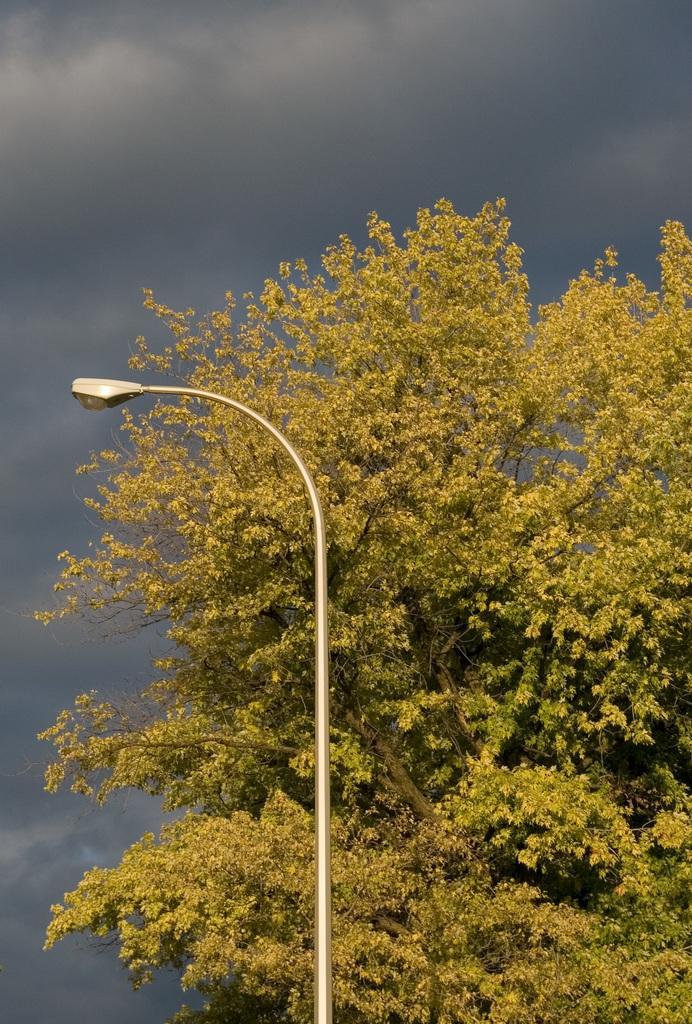Describe this image in one or two sentences. In this image I can see a tree and a light pole. In the background I can see the sky. 